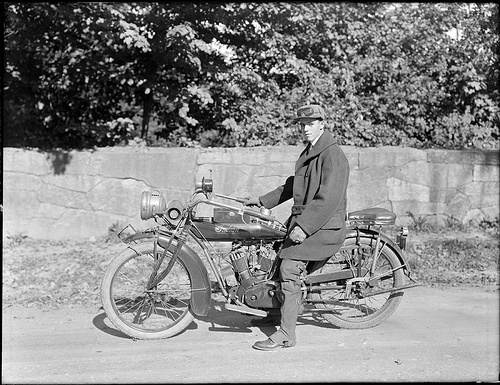Describe the objects in this image and their specific colors. I can see motorcycle in black, darkgray, gray, and lightgray tones and people in black, gray, and lightgray tones in this image. 